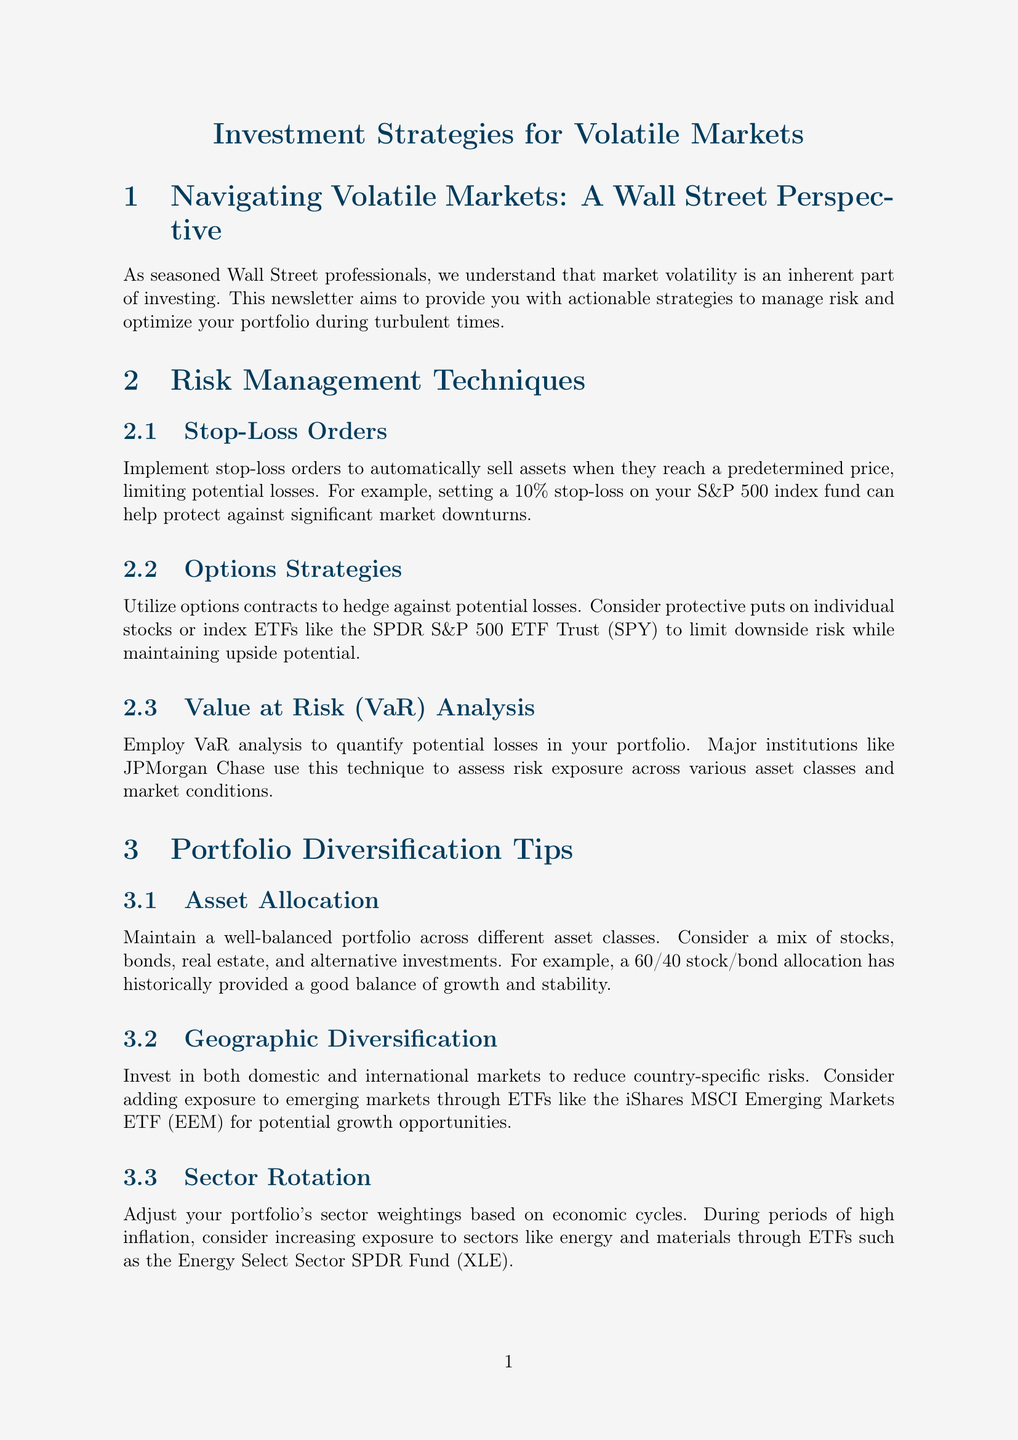What is the title of the newsletter? The title of the newsletter is the main heading that indicates the topic of the document, which is "Investment Strategies for Volatile Markets."
Answer: Investment Strategies for Volatile Markets What is an example of a risk management technique mentioned? This refers to specific strategies provided in the newsletter, one of which is "Stop-Loss Orders."
Answer: Stop-Loss Orders Which asset allocation is mentioned as historically providing a good balance? This question is about a specific recommendation in the newsletter regarding a portfolio mix, which is "a 60/40 stock/bond allocation."
Answer: a 60/40 stock/bond allocation What case study is discussed regarding market performance? This question focuses on the real-world example used in the newsletter to illustrate investment strategies, specifically during the COVID-19 market crash.
Answer: Weathering the 2020 Market Crash According to BlackRock, what should investors do during volatile markets? This question seeks to highlight a key piece of insight provided by a leading asset management firm in the newsletter.
Answer: Stay invested and rebalancing regularly What is a suggested ETF for geographic diversification? This question targets specific investment products recommended in the newsletter for reducing risks associated with specific regions, specifically mentioning an ETF example.
Answer: iShares MSCI Emerging Markets ETF During periods of high inflation, which sectors should investors consider increasing exposure to? This requires synthesizing information about market conditions and strategic positioning from the newsletter, focusing on sectors highlighted for their potential during inflation.
Answer: Energy and materials What is the goal of employing Value at Risk analysis? This refers to the purpose behind a specific risk assessment methodology discussed in the newsletter.
Answer: Quantify potential losses 